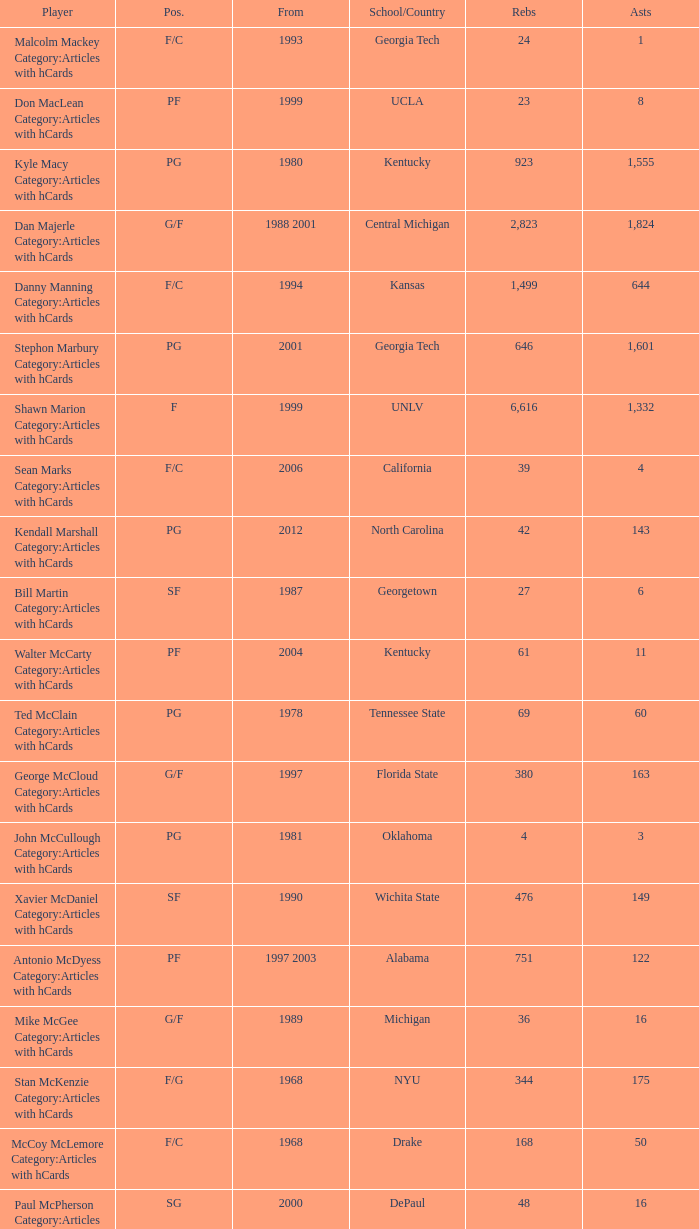Who has the top assists in 2000? 16.0. 